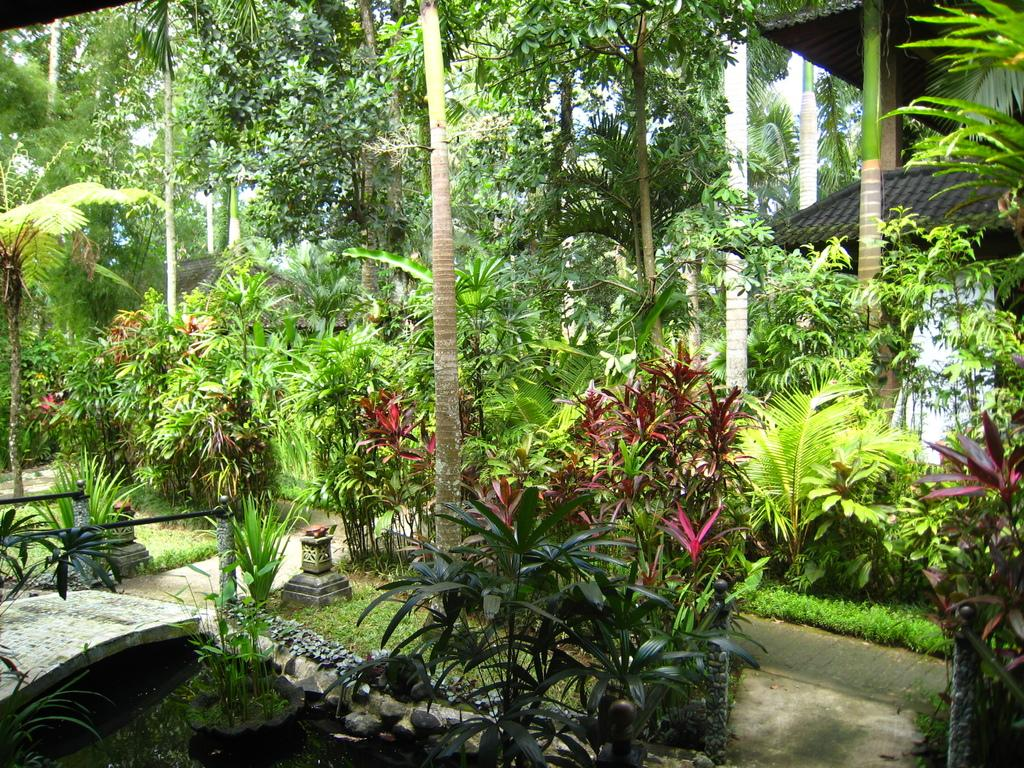What type of vegetation can be seen in the image? There are trees, plants, and flower pots with plants in the image. Where is the house located in the image? The house is on the right side of the image. What is present at the bottom of the image? There is grass, flower pots with plants, and water at the bottom of the image. What pathway can be seen in the image? There is a walkway in the image. What other objects are present in the image? There are other objects in the image, but their specific details are not mentioned in the provided facts. Where is the library located in the image? There is no mention of a library in the provided facts, so its location cannot be determined from the image. What type of butter is being used to water the plants in the image? There is no butter present in the image, and plants do not require butter for watering. 